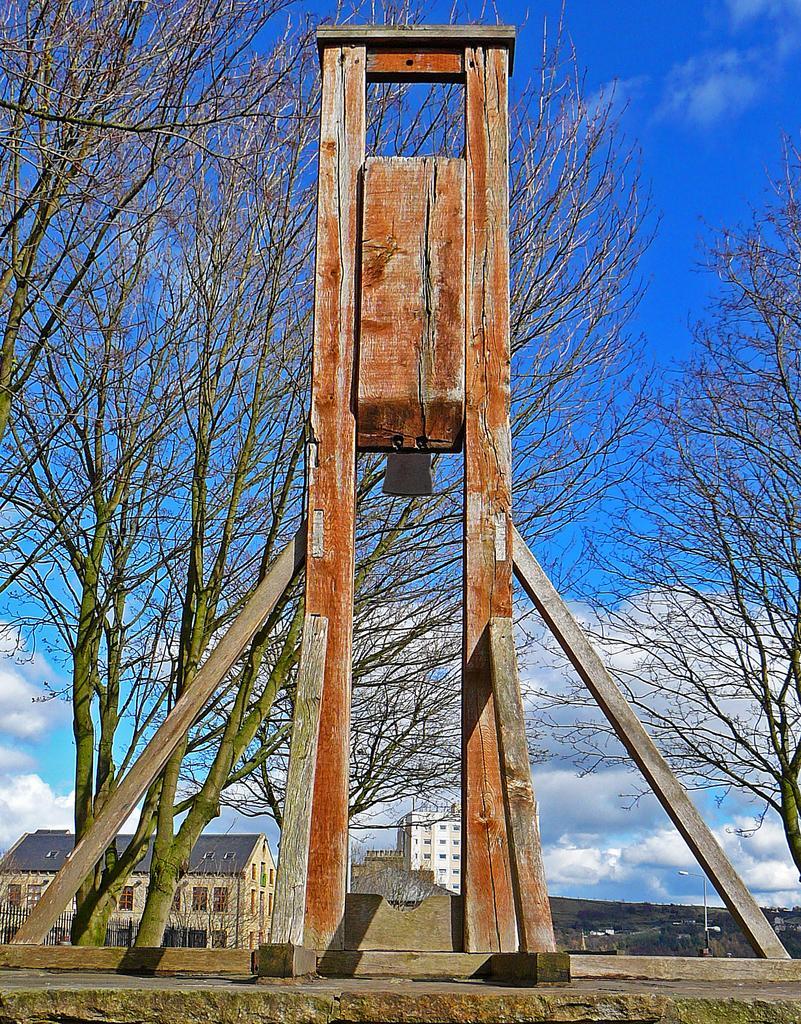Describe this image in one or two sentences. In this image I can see few wooden poles which are brown and ash in color and in the background I can see few trees, few buildings and the sky. 